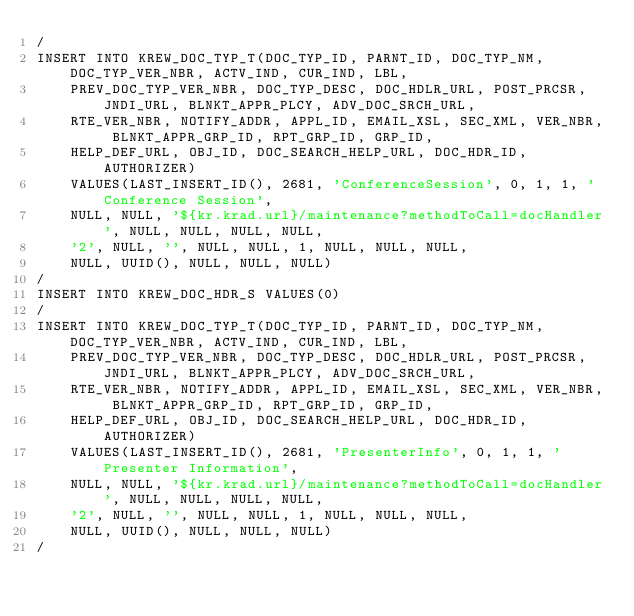Convert code to text. <code><loc_0><loc_0><loc_500><loc_500><_SQL_>/
INSERT INTO KREW_DOC_TYP_T(DOC_TYP_ID, PARNT_ID, DOC_TYP_NM, DOC_TYP_VER_NBR, ACTV_IND, CUR_IND, LBL, 
    PREV_DOC_TYP_VER_NBR, DOC_TYP_DESC, DOC_HDLR_URL, POST_PRCSR, JNDI_URL, BLNKT_APPR_PLCY, ADV_DOC_SRCH_URL, 
    RTE_VER_NBR, NOTIFY_ADDR, APPL_ID, EMAIL_XSL, SEC_XML, VER_NBR, BLNKT_APPR_GRP_ID, RPT_GRP_ID, GRP_ID, 
    HELP_DEF_URL, OBJ_ID, DOC_SEARCH_HELP_URL, DOC_HDR_ID, AUTHORIZER) 
	VALUES(LAST_INSERT_ID(), 2681, 'ConferenceSession', 0, 1, 1, 'Conference Session', 
    NULL, NULL, '${kr.krad.url}/maintenance?methodToCall=docHandler', NULL, NULL, NULL, NULL, 
    '2', NULL, '', NULL, NULL, 1, NULL, NULL, NULL, 
    NULL, UUID(), NULL, NULL, NULL)
/
INSERT INTO KREW_DOC_HDR_S VALUES(0)
/
INSERT INTO KREW_DOC_TYP_T(DOC_TYP_ID, PARNT_ID, DOC_TYP_NM, DOC_TYP_VER_NBR, ACTV_IND, CUR_IND, LBL, 
    PREV_DOC_TYP_VER_NBR, DOC_TYP_DESC, DOC_HDLR_URL, POST_PRCSR, JNDI_URL, BLNKT_APPR_PLCY, ADV_DOC_SRCH_URL, 
    RTE_VER_NBR, NOTIFY_ADDR, APPL_ID, EMAIL_XSL, SEC_XML, VER_NBR, BLNKT_APPR_GRP_ID, RPT_GRP_ID, GRP_ID, 
    HELP_DEF_URL, OBJ_ID, DOC_SEARCH_HELP_URL, DOC_HDR_ID, AUTHORIZER) 
	VALUES(LAST_INSERT_ID(), 2681, 'PresenterInfo', 0, 1, 1, 'Presenter Information', 
    NULL, NULL, '${kr.krad.url}/maintenance?methodToCall=docHandler', NULL, NULL, NULL, NULL, 
    '2', NULL, '', NULL, NULL, 1, NULL, NULL, NULL, 
    NULL, UUID(), NULL, NULL, NULL)
/</code> 